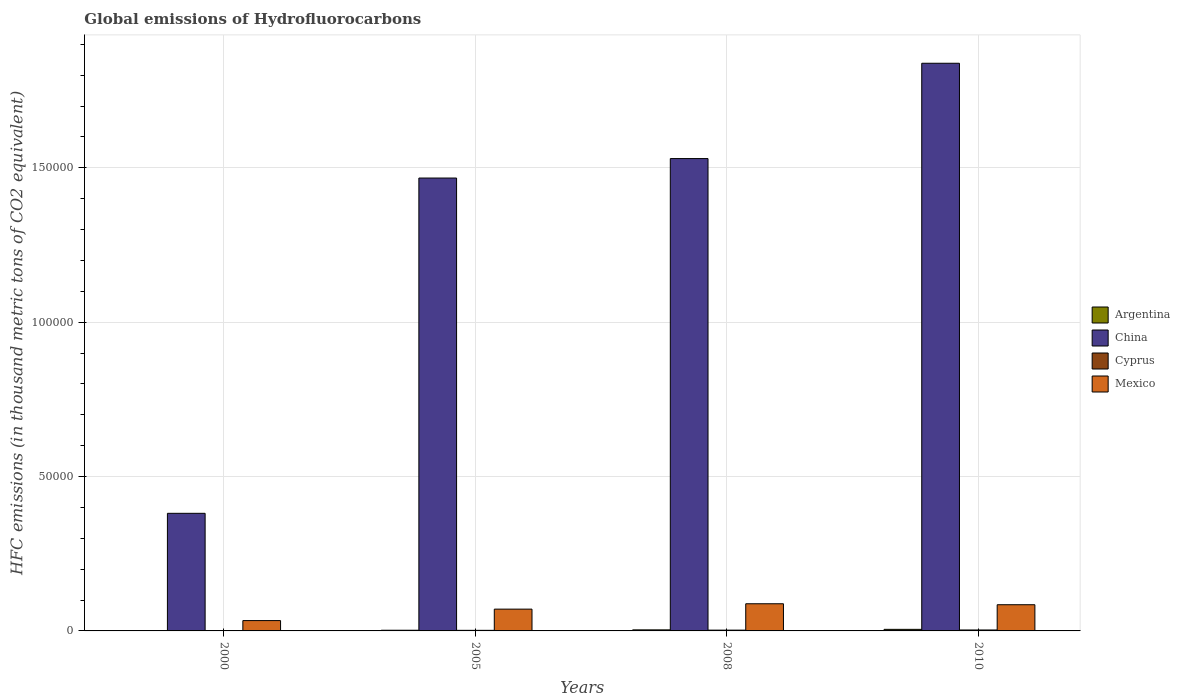How many different coloured bars are there?
Your response must be concise. 4. How many groups of bars are there?
Offer a terse response. 4. Are the number of bars on each tick of the X-axis equal?
Your response must be concise. Yes. What is the global emissions of Hydrofluorocarbons in China in 2010?
Your answer should be very brief. 1.84e+05. Across all years, what is the maximum global emissions of Hydrofluorocarbons in Mexico?
Make the answer very short. 8796.9. In which year was the global emissions of Hydrofluorocarbons in Mexico maximum?
Offer a very short reply. 2008. In which year was the global emissions of Hydrofluorocarbons in China minimum?
Keep it short and to the point. 2000. What is the total global emissions of Hydrofluorocarbons in Argentina in the graph?
Keep it short and to the point. 1127.1. What is the difference between the global emissions of Hydrofluorocarbons in Cyprus in 2000 and that in 2005?
Your response must be concise. -109.9. What is the difference between the global emissions of Hydrofluorocarbons in Mexico in 2000 and the global emissions of Hydrofluorocarbons in Argentina in 2010?
Provide a short and direct response. 2841.3. What is the average global emissions of Hydrofluorocarbons in Argentina per year?
Offer a terse response. 281.77. In the year 2005, what is the difference between the global emissions of Hydrofluorocarbons in Mexico and global emissions of Hydrofluorocarbons in China?
Your answer should be very brief. -1.40e+05. In how many years, is the global emissions of Hydrofluorocarbons in Cyprus greater than 80000 thousand metric tons?
Give a very brief answer. 0. What is the ratio of the global emissions of Hydrofluorocarbons in Argentina in 2000 to that in 2010?
Ensure brevity in your answer.  0.12. Is the difference between the global emissions of Hydrofluorocarbons in Mexico in 2000 and 2008 greater than the difference between the global emissions of Hydrofluorocarbons in China in 2000 and 2008?
Keep it short and to the point. Yes. What is the difference between the highest and the second highest global emissions of Hydrofluorocarbons in China?
Your answer should be very brief. 3.09e+04. What is the difference between the highest and the lowest global emissions of Hydrofluorocarbons in Cyprus?
Offer a terse response. 225.6. Is the sum of the global emissions of Hydrofluorocarbons in Cyprus in 2005 and 2010 greater than the maximum global emissions of Hydrofluorocarbons in China across all years?
Make the answer very short. No. What does the 3rd bar from the left in 2010 represents?
Keep it short and to the point. Cyprus. Is it the case that in every year, the sum of the global emissions of Hydrofluorocarbons in Mexico and global emissions of Hydrofluorocarbons in Argentina is greater than the global emissions of Hydrofluorocarbons in China?
Ensure brevity in your answer.  No. What is the difference between two consecutive major ticks on the Y-axis?
Your answer should be very brief. 5.00e+04. Does the graph contain any zero values?
Provide a succinct answer. No. Where does the legend appear in the graph?
Your answer should be compact. Center right. How many legend labels are there?
Keep it short and to the point. 4. How are the legend labels stacked?
Keep it short and to the point. Vertical. What is the title of the graph?
Offer a terse response. Global emissions of Hydrofluorocarbons. What is the label or title of the X-axis?
Your answer should be very brief. Years. What is the label or title of the Y-axis?
Your answer should be very brief. HFC emissions (in thousand metric tons of CO2 equivalent). What is the HFC emissions (in thousand metric tons of CO2 equivalent) of Argentina in 2000?
Provide a succinct answer. 63. What is the HFC emissions (in thousand metric tons of CO2 equivalent) of China in 2000?
Offer a terse response. 3.81e+04. What is the HFC emissions (in thousand metric tons of CO2 equivalent) in Cyprus in 2000?
Provide a succinct answer. 78.4. What is the HFC emissions (in thousand metric tons of CO2 equivalent) in Mexico in 2000?
Give a very brief answer. 3347.3. What is the HFC emissions (in thousand metric tons of CO2 equivalent) of Argentina in 2005?
Your answer should be very brief. 218.1. What is the HFC emissions (in thousand metric tons of CO2 equivalent) of China in 2005?
Provide a succinct answer. 1.47e+05. What is the HFC emissions (in thousand metric tons of CO2 equivalent) in Cyprus in 2005?
Provide a succinct answer. 188.3. What is the HFC emissions (in thousand metric tons of CO2 equivalent) of Mexico in 2005?
Ensure brevity in your answer.  7058.9. What is the HFC emissions (in thousand metric tons of CO2 equivalent) of Argentina in 2008?
Ensure brevity in your answer.  340. What is the HFC emissions (in thousand metric tons of CO2 equivalent) of China in 2008?
Offer a very short reply. 1.53e+05. What is the HFC emissions (in thousand metric tons of CO2 equivalent) in Cyprus in 2008?
Ensure brevity in your answer.  256.1. What is the HFC emissions (in thousand metric tons of CO2 equivalent) in Mexico in 2008?
Your answer should be compact. 8796.9. What is the HFC emissions (in thousand metric tons of CO2 equivalent) of Argentina in 2010?
Your answer should be very brief. 506. What is the HFC emissions (in thousand metric tons of CO2 equivalent) in China in 2010?
Your answer should be very brief. 1.84e+05. What is the HFC emissions (in thousand metric tons of CO2 equivalent) of Cyprus in 2010?
Ensure brevity in your answer.  304. What is the HFC emissions (in thousand metric tons of CO2 equivalent) in Mexico in 2010?
Keep it short and to the point. 8485. Across all years, what is the maximum HFC emissions (in thousand metric tons of CO2 equivalent) of Argentina?
Offer a very short reply. 506. Across all years, what is the maximum HFC emissions (in thousand metric tons of CO2 equivalent) of China?
Make the answer very short. 1.84e+05. Across all years, what is the maximum HFC emissions (in thousand metric tons of CO2 equivalent) of Cyprus?
Your response must be concise. 304. Across all years, what is the maximum HFC emissions (in thousand metric tons of CO2 equivalent) in Mexico?
Keep it short and to the point. 8796.9. Across all years, what is the minimum HFC emissions (in thousand metric tons of CO2 equivalent) in China?
Make the answer very short. 3.81e+04. Across all years, what is the minimum HFC emissions (in thousand metric tons of CO2 equivalent) in Cyprus?
Your answer should be very brief. 78.4. Across all years, what is the minimum HFC emissions (in thousand metric tons of CO2 equivalent) of Mexico?
Provide a short and direct response. 3347.3. What is the total HFC emissions (in thousand metric tons of CO2 equivalent) of Argentina in the graph?
Keep it short and to the point. 1127.1. What is the total HFC emissions (in thousand metric tons of CO2 equivalent) of China in the graph?
Your answer should be very brief. 5.22e+05. What is the total HFC emissions (in thousand metric tons of CO2 equivalent) of Cyprus in the graph?
Your answer should be very brief. 826.8. What is the total HFC emissions (in thousand metric tons of CO2 equivalent) of Mexico in the graph?
Your answer should be very brief. 2.77e+04. What is the difference between the HFC emissions (in thousand metric tons of CO2 equivalent) of Argentina in 2000 and that in 2005?
Offer a terse response. -155.1. What is the difference between the HFC emissions (in thousand metric tons of CO2 equivalent) of China in 2000 and that in 2005?
Your response must be concise. -1.09e+05. What is the difference between the HFC emissions (in thousand metric tons of CO2 equivalent) in Cyprus in 2000 and that in 2005?
Your answer should be compact. -109.9. What is the difference between the HFC emissions (in thousand metric tons of CO2 equivalent) of Mexico in 2000 and that in 2005?
Offer a very short reply. -3711.6. What is the difference between the HFC emissions (in thousand metric tons of CO2 equivalent) in Argentina in 2000 and that in 2008?
Offer a very short reply. -277. What is the difference between the HFC emissions (in thousand metric tons of CO2 equivalent) of China in 2000 and that in 2008?
Ensure brevity in your answer.  -1.15e+05. What is the difference between the HFC emissions (in thousand metric tons of CO2 equivalent) of Cyprus in 2000 and that in 2008?
Offer a very short reply. -177.7. What is the difference between the HFC emissions (in thousand metric tons of CO2 equivalent) in Mexico in 2000 and that in 2008?
Your answer should be compact. -5449.6. What is the difference between the HFC emissions (in thousand metric tons of CO2 equivalent) in Argentina in 2000 and that in 2010?
Make the answer very short. -443. What is the difference between the HFC emissions (in thousand metric tons of CO2 equivalent) in China in 2000 and that in 2010?
Provide a succinct answer. -1.46e+05. What is the difference between the HFC emissions (in thousand metric tons of CO2 equivalent) in Cyprus in 2000 and that in 2010?
Ensure brevity in your answer.  -225.6. What is the difference between the HFC emissions (in thousand metric tons of CO2 equivalent) in Mexico in 2000 and that in 2010?
Provide a succinct answer. -5137.7. What is the difference between the HFC emissions (in thousand metric tons of CO2 equivalent) of Argentina in 2005 and that in 2008?
Provide a succinct answer. -121.9. What is the difference between the HFC emissions (in thousand metric tons of CO2 equivalent) in China in 2005 and that in 2008?
Keep it short and to the point. -6309. What is the difference between the HFC emissions (in thousand metric tons of CO2 equivalent) of Cyprus in 2005 and that in 2008?
Provide a short and direct response. -67.8. What is the difference between the HFC emissions (in thousand metric tons of CO2 equivalent) of Mexico in 2005 and that in 2008?
Ensure brevity in your answer.  -1738. What is the difference between the HFC emissions (in thousand metric tons of CO2 equivalent) in Argentina in 2005 and that in 2010?
Provide a short and direct response. -287.9. What is the difference between the HFC emissions (in thousand metric tons of CO2 equivalent) in China in 2005 and that in 2010?
Ensure brevity in your answer.  -3.72e+04. What is the difference between the HFC emissions (in thousand metric tons of CO2 equivalent) in Cyprus in 2005 and that in 2010?
Provide a short and direct response. -115.7. What is the difference between the HFC emissions (in thousand metric tons of CO2 equivalent) of Mexico in 2005 and that in 2010?
Your response must be concise. -1426.1. What is the difference between the HFC emissions (in thousand metric tons of CO2 equivalent) in Argentina in 2008 and that in 2010?
Your response must be concise. -166. What is the difference between the HFC emissions (in thousand metric tons of CO2 equivalent) of China in 2008 and that in 2010?
Your answer should be compact. -3.09e+04. What is the difference between the HFC emissions (in thousand metric tons of CO2 equivalent) in Cyprus in 2008 and that in 2010?
Your response must be concise. -47.9. What is the difference between the HFC emissions (in thousand metric tons of CO2 equivalent) in Mexico in 2008 and that in 2010?
Make the answer very short. 311.9. What is the difference between the HFC emissions (in thousand metric tons of CO2 equivalent) in Argentina in 2000 and the HFC emissions (in thousand metric tons of CO2 equivalent) in China in 2005?
Your response must be concise. -1.47e+05. What is the difference between the HFC emissions (in thousand metric tons of CO2 equivalent) of Argentina in 2000 and the HFC emissions (in thousand metric tons of CO2 equivalent) of Cyprus in 2005?
Ensure brevity in your answer.  -125.3. What is the difference between the HFC emissions (in thousand metric tons of CO2 equivalent) in Argentina in 2000 and the HFC emissions (in thousand metric tons of CO2 equivalent) in Mexico in 2005?
Give a very brief answer. -6995.9. What is the difference between the HFC emissions (in thousand metric tons of CO2 equivalent) of China in 2000 and the HFC emissions (in thousand metric tons of CO2 equivalent) of Cyprus in 2005?
Make the answer very short. 3.79e+04. What is the difference between the HFC emissions (in thousand metric tons of CO2 equivalent) of China in 2000 and the HFC emissions (in thousand metric tons of CO2 equivalent) of Mexico in 2005?
Your answer should be very brief. 3.10e+04. What is the difference between the HFC emissions (in thousand metric tons of CO2 equivalent) of Cyprus in 2000 and the HFC emissions (in thousand metric tons of CO2 equivalent) of Mexico in 2005?
Your answer should be compact. -6980.5. What is the difference between the HFC emissions (in thousand metric tons of CO2 equivalent) in Argentina in 2000 and the HFC emissions (in thousand metric tons of CO2 equivalent) in China in 2008?
Your response must be concise. -1.53e+05. What is the difference between the HFC emissions (in thousand metric tons of CO2 equivalent) in Argentina in 2000 and the HFC emissions (in thousand metric tons of CO2 equivalent) in Cyprus in 2008?
Give a very brief answer. -193.1. What is the difference between the HFC emissions (in thousand metric tons of CO2 equivalent) of Argentina in 2000 and the HFC emissions (in thousand metric tons of CO2 equivalent) of Mexico in 2008?
Your answer should be very brief. -8733.9. What is the difference between the HFC emissions (in thousand metric tons of CO2 equivalent) in China in 2000 and the HFC emissions (in thousand metric tons of CO2 equivalent) in Cyprus in 2008?
Provide a short and direct response. 3.78e+04. What is the difference between the HFC emissions (in thousand metric tons of CO2 equivalent) in China in 2000 and the HFC emissions (in thousand metric tons of CO2 equivalent) in Mexico in 2008?
Provide a succinct answer. 2.93e+04. What is the difference between the HFC emissions (in thousand metric tons of CO2 equivalent) in Cyprus in 2000 and the HFC emissions (in thousand metric tons of CO2 equivalent) in Mexico in 2008?
Your answer should be compact. -8718.5. What is the difference between the HFC emissions (in thousand metric tons of CO2 equivalent) of Argentina in 2000 and the HFC emissions (in thousand metric tons of CO2 equivalent) of China in 2010?
Give a very brief answer. -1.84e+05. What is the difference between the HFC emissions (in thousand metric tons of CO2 equivalent) in Argentina in 2000 and the HFC emissions (in thousand metric tons of CO2 equivalent) in Cyprus in 2010?
Offer a very short reply. -241. What is the difference between the HFC emissions (in thousand metric tons of CO2 equivalent) of Argentina in 2000 and the HFC emissions (in thousand metric tons of CO2 equivalent) of Mexico in 2010?
Your response must be concise. -8422. What is the difference between the HFC emissions (in thousand metric tons of CO2 equivalent) in China in 2000 and the HFC emissions (in thousand metric tons of CO2 equivalent) in Cyprus in 2010?
Provide a succinct answer. 3.78e+04. What is the difference between the HFC emissions (in thousand metric tons of CO2 equivalent) in China in 2000 and the HFC emissions (in thousand metric tons of CO2 equivalent) in Mexico in 2010?
Your response must be concise. 2.96e+04. What is the difference between the HFC emissions (in thousand metric tons of CO2 equivalent) in Cyprus in 2000 and the HFC emissions (in thousand metric tons of CO2 equivalent) in Mexico in 2010?
Give a very brief answer. -8406.6. What is the difference between the HFC emissions (in thousand metric tons of CO2 equivalent) in Argentina in 2005 and the HFC emissions (in thousand metric tons of CO2 equivalent) in China in 2008?
Your answer should be very brief. -1.53e+05. What is the difference between the HFC emissions (in thousand metric tons of CO2 equivalent) in Argentina in 2005 and the HFC emissions (in thousand metric tons of CO2 equivalent) in Cyprus in 2008?
Make the answer very short. -38. What is the difference between the HFC emissions (in thousand metric tons of CO2 equivalent) in Argentina in 2005 and the HFC emissions (in thousand metric tons of CO2 equivalent) in Mexico in 2008?
Your response must be concise. -8578.8. What is the difference between the HFC emissions (in thousand metric tons of CO2 equivalent) in China in 2005 and the HFC emissions (in thousand metric tons of CO2 equivalent) in Cyprus in 2008?
Provide a succinct answer. 1.46e+05. What is the difference between the HFC emissions (in thousand metric tons of CO2 equivalent) in China in 2005 and the HFC emissions (in thousand metric tons of CO2 equivalent) in Mexico in 2008?
Offer a terse response. 1.38e+05. What is the difference between the HFC emissions (in thousand metric tons of CO2 equivalent) in Cyprus in 2005 and the HFC emissions (in thousand metric tons of CO2 equivalent) in Mexico in 2008?
Keep it short and to the point. -8608.6. What is the difference between the HFC emissions (in thousand metric tons of CO2 equivalent) in Argentina in 2005 and the HFC emissions (in thousand metric tons of CO2 equivalent) in China in 2010?
Offer a terse response. -1.84e+05. What is the difference between the HFC emissions (in thousand metric tons of CO2 equivalent) in Argentina in 2005 and the HFC emissions (in thousand metric tons of CO2 equivalent) in Cyprus in 2010?
Your answer should be very brief. -85.9. What is the difference between the HFC emissions (in thousand metric tons of CO2 equivalent) of Argentina in 2005 and the HFC emissions (in thousand metric tons of CO2 equivalent) of Mexico in 2010?
Give a very brief answer. -8266.9. What is the difference between the HFC emissions (in thousand metric tons of CO2 equivalent) of China in 2005 and the HFC emissions (in thousand metric tons of CO2 equivalent) of Cyprus in 2010?
Offer a very short reply. 1.46e+05. What is the difference between the HFC emissions (in thousand metric tons of CO2 equivalent) in China in 2005 and the HFC emissions (in thousand metric tons of CO2 equivalent) in Mexico in 2010?
Keep it short and to the point. 1.38e+05. What is the difference between the HFC emissions (in thousand metric tons of CO2 equivalent) of Cyprus in 2005 and the HFC emissions (in thousand metric tons of CO2 equivalent) of Mexico in 2010?
Offer a very short reply. -8296.7. What is the difference between the HFC emissions (in thousand metric tons of CO2 equivalent) in Argentina in 2008 and the HFC emissions (in thousand metric tons of CO2 equivalent) in China in 2010?
Provide a succinct answer. -1.84e+05. What is the difference between the HFC emissions (in thousand metric tons of CO2 equivalent) in Argentina in 2008 and the HFC emissions (in thousand metric tons of CO2 equivalent) in Mexico in 2010?
Offer a very short reply. -8145. What is the difference between the HFC emissions (in thousand metric tons of CO2 equivalent) of China in 2008 and the HFC emissions (in thousand metric tons of CO2 equivalent) of Cyprus in 2010?
Ensure brevity in your answer.  1.53e+05. What is the difference between the HFC emissions (in thousand metric tons of CO2 equivalent) in China in 2008 and the HFC emissions (in thousand metric tons of CO2 equivalent) in Mexico in 2010?
Provide a short and direct response. 1.45e+05. What is the difference between the HFC emissions (in thousand metric tons of CO2 equivalent) of Cyprus in 2008 and the HFC emissions (in thousand metric tons of CO2 equivalent) of Mexico in 2010?
Offer a terse response. -8228.9. What is the average HFC emissions (in thousand metric tons of CO2 equivalent) in Argentina per year?
Keep it short and to the point. 281.77. What is the average HFC emissions (in thousand metric tons of CO2 equivalent) in China per year?
Your answer should be very brief. 1.30e+05. What is the average HFC emissions (in thousand metric tons of CO2 equivalent) of Cyprus per year?
Make the answer very short. 206.7. What is the average HFC emissions (in thousand metric tons of CO2 equivalent) of Mexico per year?
Ensure brevity in your answer.  6922.02. In the year 2000, what is the difference between the HFC emissions (in thousand metric tons of CO2 equivalent) of Argentina and HFC emissions (in thousand metric tons of CO2 equivalent) of China?
Make the answer very short. -3.80e+04. In the year 2000, what is the difference between the HFC emissions (in thousand metric tons of CO2 equivalent) of Argentina and HFC emissions (in thousand metric tons of CO2 equivalent) of Cyprus?
Offer a very short reply. -15.4. In the year 2000, what is the difference between the HFC emissions (in thousand metric tons of CO2 equivalent) of Argentina and HFC emissions (in thousand metric tons of CO2 equivalent) of Mexico?
Your answer should be very brief. -3284.3. In the year 2000, what is the difference between the HFC emissions (in thousand metric tons of CO2 equivalent) in China and HFC emissions (in thousand metric tons of CO2 equivalent) in Cyprus?
Give a very brief answer. 3.80e+04. In the year 2000, what is the difference between the HFC emissions (in thousand metric tons of CO2 equivalent) of China and HFC emissions (in thousand metric tons of CO2 equivalent) of Mexico?
Your response must be concise. 3.47e+04. In the year 2000, what is the difference between the HFC emissions (in thousand metric tons of CO2 equivalent) in Cyprus and HFC emissions (in thousand metric tons of CO2 equivalent) in Mexico?
Your answer should be compact. -3268.9. In the year 2005, what is the difference between the HFC emissions (in thousand metric tons of CO2 equivalent) in Argentina and HFC emissions (in thousand metric tons of CO2 equivalent) in China?
Your answer should be very brief. -1.46e+05. In the year 2005, what is the difference between the HFC emissions (in thousand metric tons of CO2 equivalent) of Argentina and HFC emissions (in thousand metric tons of CO2 equivalent) of Cyprus?
Offer a terse response. 29.8. In the year 2005, what is the difference between the HFC emissions (in thousand metric tons of CO2 equivalent) in Argentina and HFC emissions (in thousand metric tons of CO2 equivalent) in Mexico?
Make the answer very short. -6840.8. In the year 2005, what is the difference between the HFC emissions (in thousand metric tons of CO2 equivalent) in China and HFC emissions (in thousand metric tons of CO2 equivalent) in Cyprus?
Offer a terse response. 1.47e+05. In the year 2005, what is the difference between the HFC emissions (in thousand metric tons of CO2 equivalent) in China and HFC emissions (in thousand metric tons of CO2 equivalent) in Mexico?
Make the answer very short. 1.40e+05. In the year 2005, what is the difference between the HFC emissions (in thousand metric tons of CO2 equivalent) of Cyprus and HFC emissions (in thousand metric tons of CO2 equivalent) of Mexico?
Provide a short and direct response. -6870.6. In the year 2008, what is the difference between the HFC emissions (in thousand metric tons of CO2 equivalent) in Argentina and HFC emissions (in thousand metric tons of CO2 equivalent) in China?
Your response must be concise. -1.53e+05. In the year 2008, what is the difference between the HFC emissions (in thousand metric tons of CO2 equivalent) in Argentina and HFC emissions (in thousand metric tons of CO2 equivalent) in Cyprus?
Your response must be concise. 83.9. In the year 2008, what is the difference between the HFC emissions (in thousand metric tons of CO2 equivalent) in Argentina and HFC emissions (in thousand metric tons of CO2 equivalent) in Mexico?
Ensure brevity in your answer.  -8456.9. In the year 2008, what is the difference between the HFC emissions (in thousand metric tons of CO2 equivalent) of China and HFC emissions (in thousand metric tons of CO2 equivalent) of Cyprus?
Give a very brief answer. 1.53e+05. In the year 2008, what is the difference between the HFC emissions (in thousand metric tons of CO2 equivalent) of China and HFC emissions (in thousand metric tons of CO2 equivalent) of Mexico?
Give a very brief answer. 1.44e+05. In the year 2008, what is the difference between the HFC emissions (in thousand metric tons of CO2 equivalent) of Cyprus and HFC emissions (in thousand metric tons of CO2 equivalent) of Mexico?
Provide a succinct answer. -8540.8. In the year 2010, what is the difference between the HFC emissions (in thousand metric tons of CO2 equivalent) of Argentina and HFC emissions (in thousand metric tons of CO2 equivalent) of China?
Give a very brief answer. -1.83e+05. In the year 2010, what is the difference between the HFC emissions (in thousand metric tons of CO2 equivalent) in Argentina and HFC emissions (in thousand metric tons of CO2 equivalent) in Cyprus?
Ensure brevity in your answer.  202. In the year 2010, what is the difference between the HFC emissions (in thousand metric tons of CO2 equivalent) of Argentina and HFC emissions (in thousand metric tons of CO2 equivalent) of Mexico?
Your response must be concise. -7979. In the year 2010, what is the difference between the HFC emissions (in thousand metric tons of CO2 equivalent) of China and HFC emissions (in thousand metric tons of CO2 equivalent) of Cyprus?
Offer a very short reply. 1.84e+05. In the year 2010, what is the difference between the HFC emissions (in thousand metric tons of CO2 equivalent) of China and HFC emissions (in thousand metric tons of CO2 equivalent) of Mexico?
Keep it short and to the point. 1.75e+05. In the year 2010, what is the difference between the HFC emissions (in thousand metric tons of CO2 equivalent) of Cyprus and HFC emissions (in thousand metric tons of CO2 equivalent) of Mexico?
Provide a short and direct response. -8181. What is the ratio of the HFC emissions (in thousand metric tons of CO2 equivalent) of Argentina in 2000 to that in 2005?
Provide a succinct answer. 0.29. What is the ratio of the HFC emissions (in thousand metric tons of CO2 equivalent) in China in 2000 to that in 2005?
Your answer should be very brief. 0.26. What is the ratio of the HFC emissions (in thousand metric tons of CO2 equivalent) of Cyprus in 2000 to that in 2005?
Your answer should be very brief. 0.42. What is the ratio of the HFC emissions (in thousand metric tons of CO2 equivalent) of Mexico in 2000 to that in 2005?
Your answer should be compact. 0.47. What is the ratio of the HFC emissions (in thousand metric tons of CO2 equivalent) of Argentina in 2000 to that in 2008?
Make the answer very short. 0.19. What is the ratio of the HFC emissions (in thousand metric tons of CO2 equivalent) of China in 2000 to that in 2008?
Your response must be concise. 0.25. What is the ratio of the HFC emissions (in thousand metric tons of CO2 equivalent) of Cyprus in 2000 to that in 2008?
Make the answer very short. 0.31. What is the ratio of the HFC emissions (in thousand metric tons of CO2 equivalent) of Mexico in 2000 to that in 2008?
Ensure brevity in your answer.  0.38. What is the ratio of the HFC emissions (in thousand metric tons of CO2 equivalent) of Argentina in 2000 to that in 2010?
Offer a terse response. 0.12. What is the ratio of the HFC emissions (in thousand metric tons of CO2 equivalent) of China in 2000 to that in 2010?
Make the answer very short. 0.21. What is the ratio of the HFC emissions (in thousand metric tons of CO2 equivalent) in Cyprus in 2000 to that in 2010?
Keep it short and to the point. 0.26. What is the ratio of the HFC emissions (in thousand metric tons of CO2 equivalent) in Mexico in 2000 to that in 2010?
Make the answer very short. 0.39. What is the ratio of the HFC emissions (in thousand metric tons of CO2 equivalent) of Argentina in 2005 to that in 2008?
Make the answer very short. 0.64. What is the ratio of the HFC emissions (in thousand metric tons of CO2 equivalent) in China in 2005 to that in 2008?
Provide a succinct answer. 0.96. What is the ratio of the HFC emissions (in thousand metric tons of CO2 equivalent) in Cyprus in 2005 to that in 2008?
Ensure brevity in your answer.  0.74. What is the ratio of the HFC emissions (in thousand metric tons of CO2 equivalent) of Mexico in 2005 to that in 2008?
Offer a terse response. 0.8. What is the ratio of the HFC emissions (in thousand metric tons of CO2 equivalent) in Argentina in 2005 to that in 2010?
Give a very brief answer. 0.43. What is the ratio of the HFC emissions (in thousand metric tons of CO2 equivalent) in China in 2005 to that in 2010?
Ensure brevity in your answer.  0.8. What is the ratio of the HFC emissions (in thousand metric tons of CO2 equivalent) of Cyprus in 2005 to that in 2010?
Ensure brevity in your answer.  0.62. What is the ratio of the HFC emissions (in thousand metric tons of CO2 equivalent) in Mexico in 2005 to that in 2010?
Your response must be concise. 0.83. What is the ratio of the HFC emissions (in thousand metric tons of CO2 equivalent) in Argentina in 2008 to that in 2010?
Ensure brevity in your answer.  0.67. What is the ratio of the HFC emissions (in thousand metric tons of CO2 equivalent) in China in 2008 to that in 2010?
Your answer should be very brief. 0.83. What is the ratio of the HFC emissions (in thousand metric tons of CO2 equivalent) of Cyprus in 2008 to that in 2010?
Your answer should be very brief. 0.84. What is the ratio of the HFC emissions (in thousand metric tons of CO2 equivalent) of Mexico in 2008 to that in 2010?
Give a very brief answer. 1.04. What is the difference between the highest and the second highest HFC emissions (in thousand metric tons of CO2 equivalent) in Argentina?
Provide a short and direct response. 166. What is the difference between the highest and the second highest HFC emissions (in thousand metric tons of CO2 equivalent) in China?
Your answer should be very brief. 3.09e+04. What is the difference between the highest and the second highest HFC emissions (in thousand metric tons of CO2 equivalent) in Cyprus?
Make the answer very short. 47.9. What is the difference between the highest and the second highest HFC emissions (in thousand metric tons of CO2 equivalent) in Mexico?
Offer a terse response. 311.9. What is the difference between the highest and the lowest HFC emissions (in thousand metric tons of CO2 equivalent) in Argentina?
Keep it short and to the point. 443. What is the difference between the highest and the lowest HFC emissions (in thousand metric tons of CO2 equivalent) of China?
Provide a succinct answer. 1.46e+05. What is the difference between the highest and the lowest HFC emissions (in thousand metric tons of CO2 equivalent) in Cyprus?
Provide a short and direct response. 225.6. What is the difference between the highest and the lowest HFC emissions (in thousand metric tons of CO2 equivalent) in Mexico?
Make the answer very short. 5449.6. 